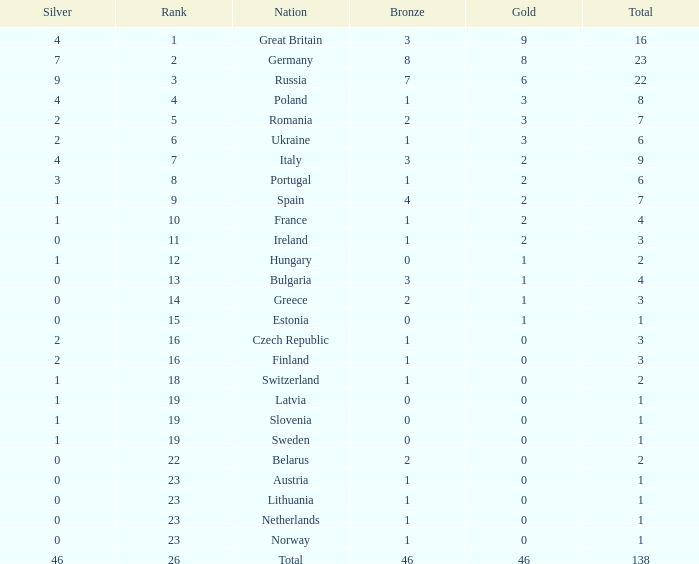When the total is larger than 1,and the bronze is less than 3, and silver larger than 2, and a gold larger than 2, what is the nation? Poland. 